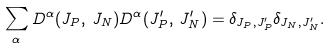<formula> <loc_0><loc_0><loc_500><loc_500>\sum _ { \alpha } D ^ { \alpha } ( J _ { P } , \, J _ { N } ) D ^ { \alpha } ( J ^ { \prime } _ { P } , \, J ^ { \prime } _ { N } ) = \delta _ { J _ { P } , J ^ { \prime } _ { P } } \delta _ { J _ { N } , J ^ { \prime } _ { N } } .</formula> 